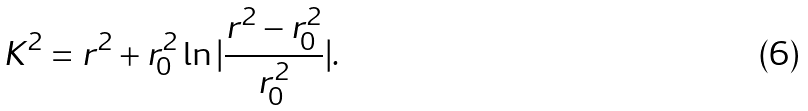Convert formula to latex. <formula><loc_0><loc_0><loc_500><loc_500>K ^ { 2 } = r ^ { 2 } + r _ { 0 } ^ { 2 } \ln | \frac { r ^ { 2 } - r _ { 0 } ^ { 2 } } { r _ { 0 } ^ { 2 } } | .</formula> 